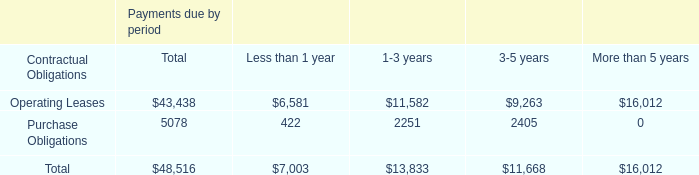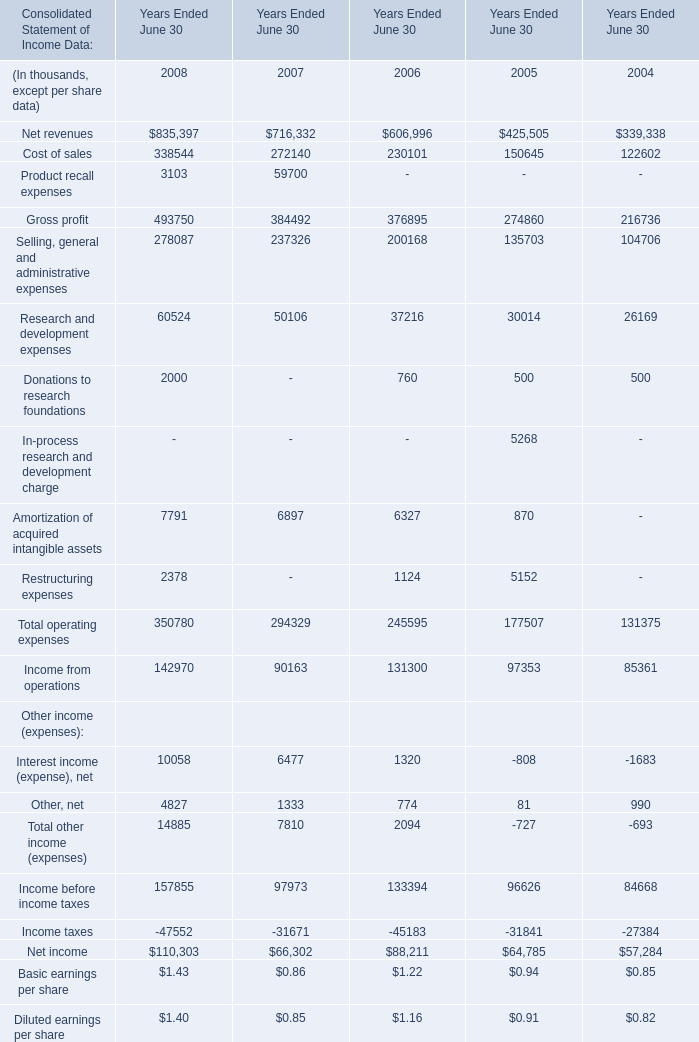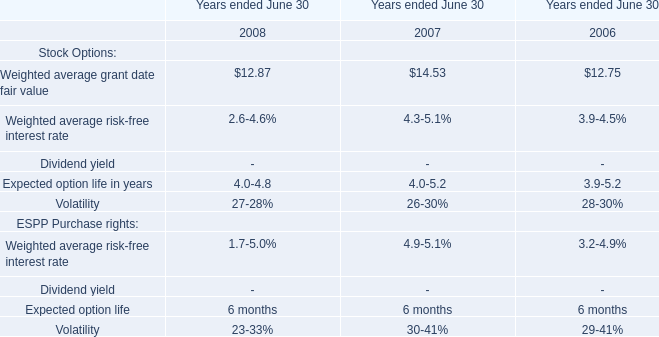What was the total amount of the Donations to research foundations in the years where Gross profit is greater than 1? 
Computations: (((2000 + 760) + 500) + 500)
Answer: 3760.0. 